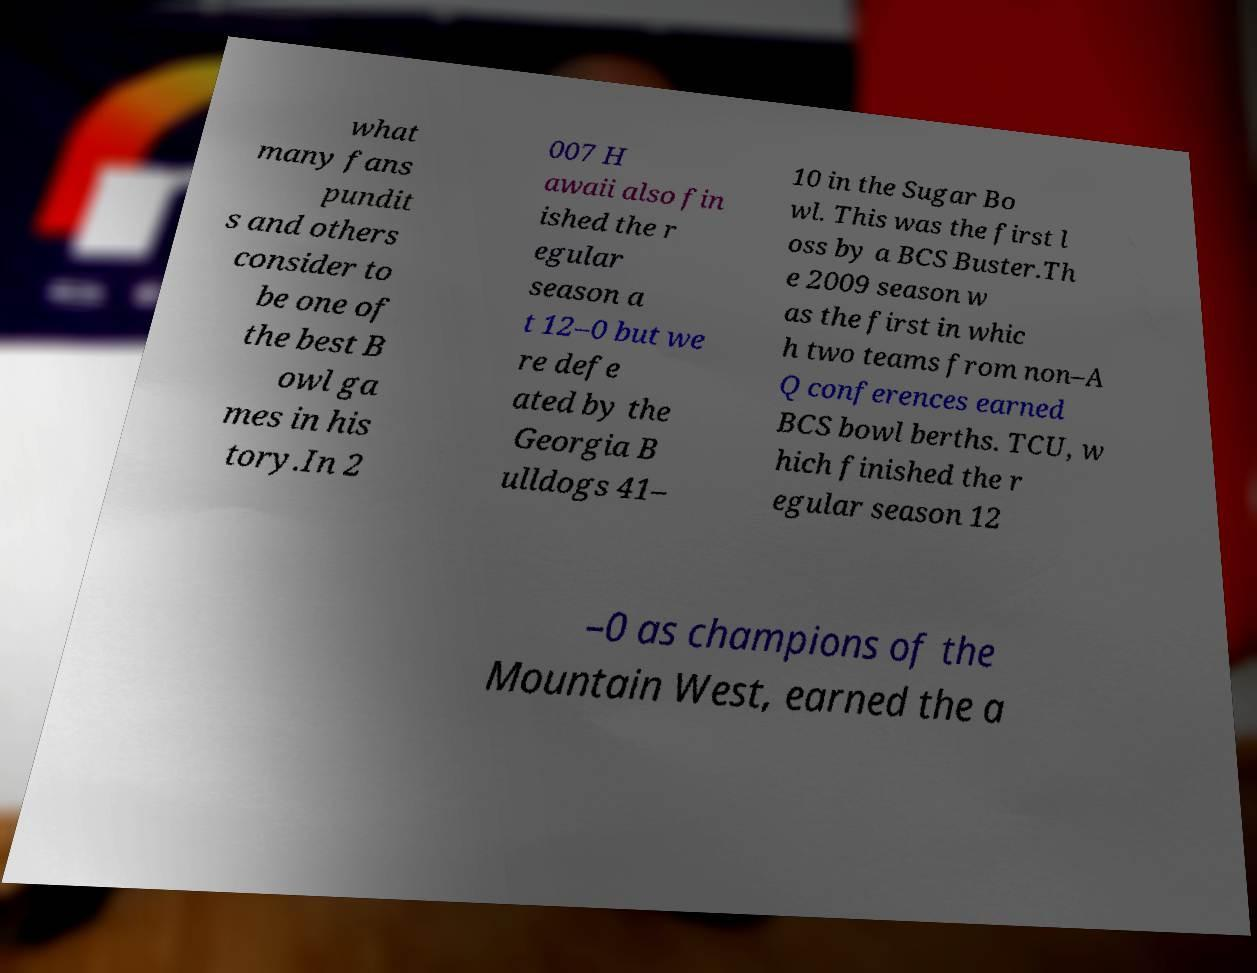Can you accurately transcribe the text from the provided image for me? what many fans pundit s and others consider to be one of the best B owl ga mes in his tory.In 2 007 H awaii also fin ished the r egular season a t 12–0 but we re defe ated by the Georgia B ulldogs 41– 10 in the Sugar Bo wl. This was the first l oss by a BCS Buster.Th e 2009 season w as the first in whic h two teams from non–A Q conferences earned BCS bowl berths. TCU, w hich finished the r egular season 12 –0 as champions of the Mountain West, earned the a 